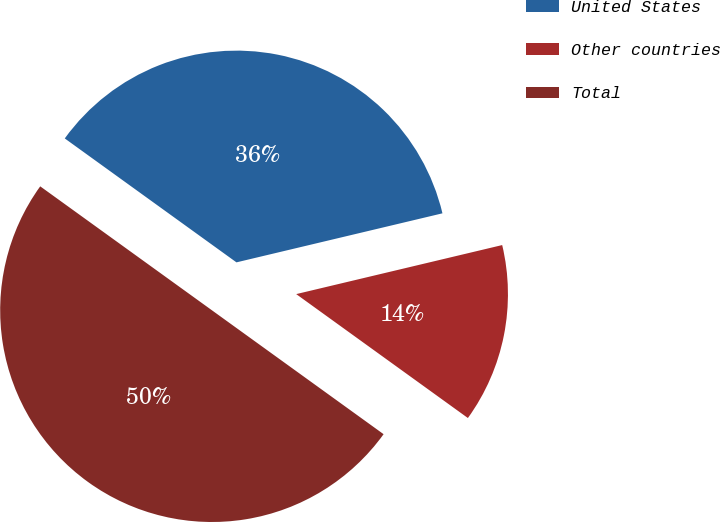Convert chart. <chart><loc_0><loc_0><loc_500><loc_500><pie_chart><fcel>United States<fcel>Other countries<fcel>Total<nl><fcel>36.33%<fcel>13.67%<fcel>50.0%<nl></chart> 